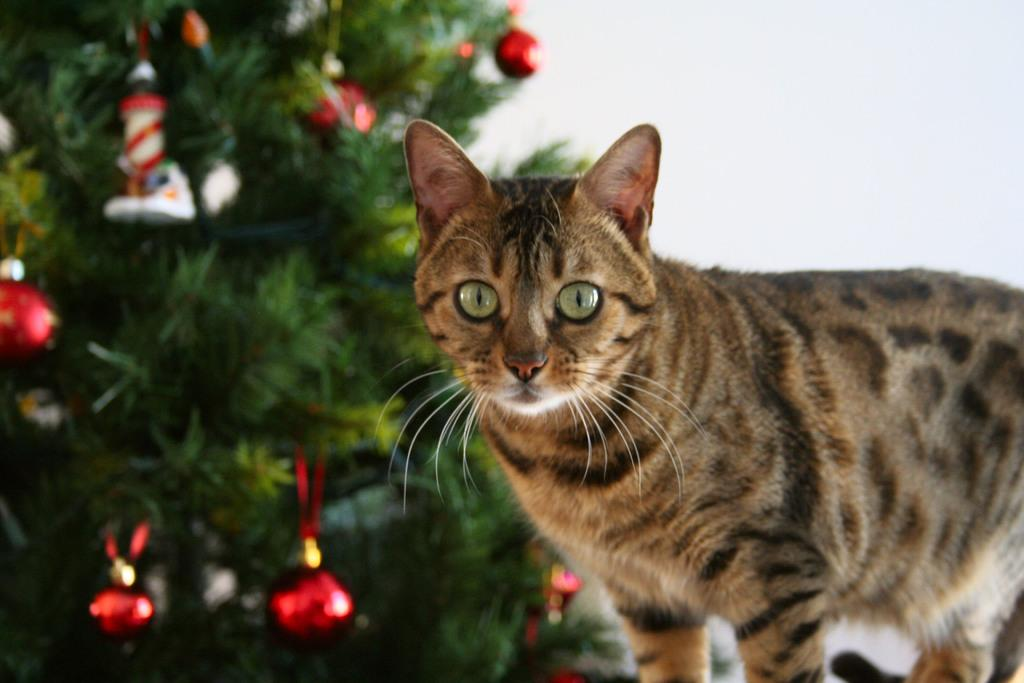What type of animal is present in the image? There is a cat in the image. What natural elements can be seen in the image? There are leaves in the image. What additional objects are present in the image? There are decorative objects in the image. What is the color of the background in the image? The background of the image is white. Can you hear the sound of thunder in the image? There is no sound present in the image, and therefore no thunder can be heard. 